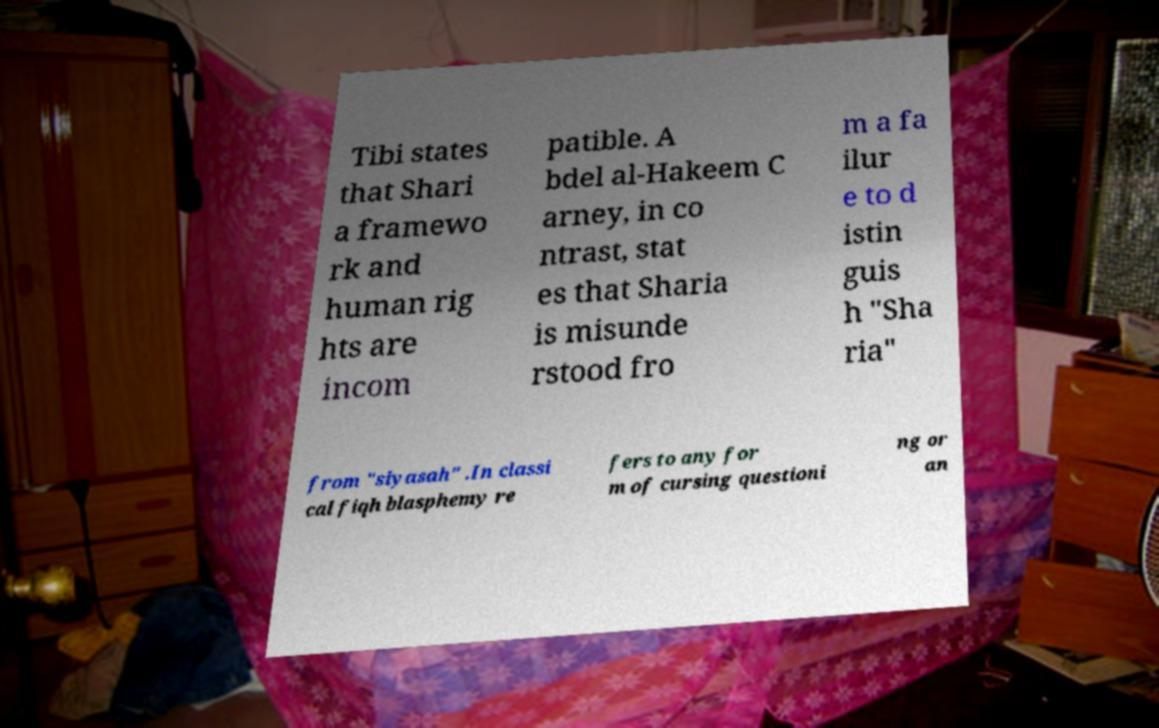What messages or text are displayed in this image? I need them in a readable, typed format. Tibi states that Shari a framewo rk and human rig hts are incom patible. A bdel al-Hakeem C arney, in co ntrast, stat es that Sharia is misunde rstood fro m a fa ilur e to d istin guis h "Sha ria" from "siyasah" .In classi cal fiqh blasphemy re fers to any for m of cursing questioni ng or an 